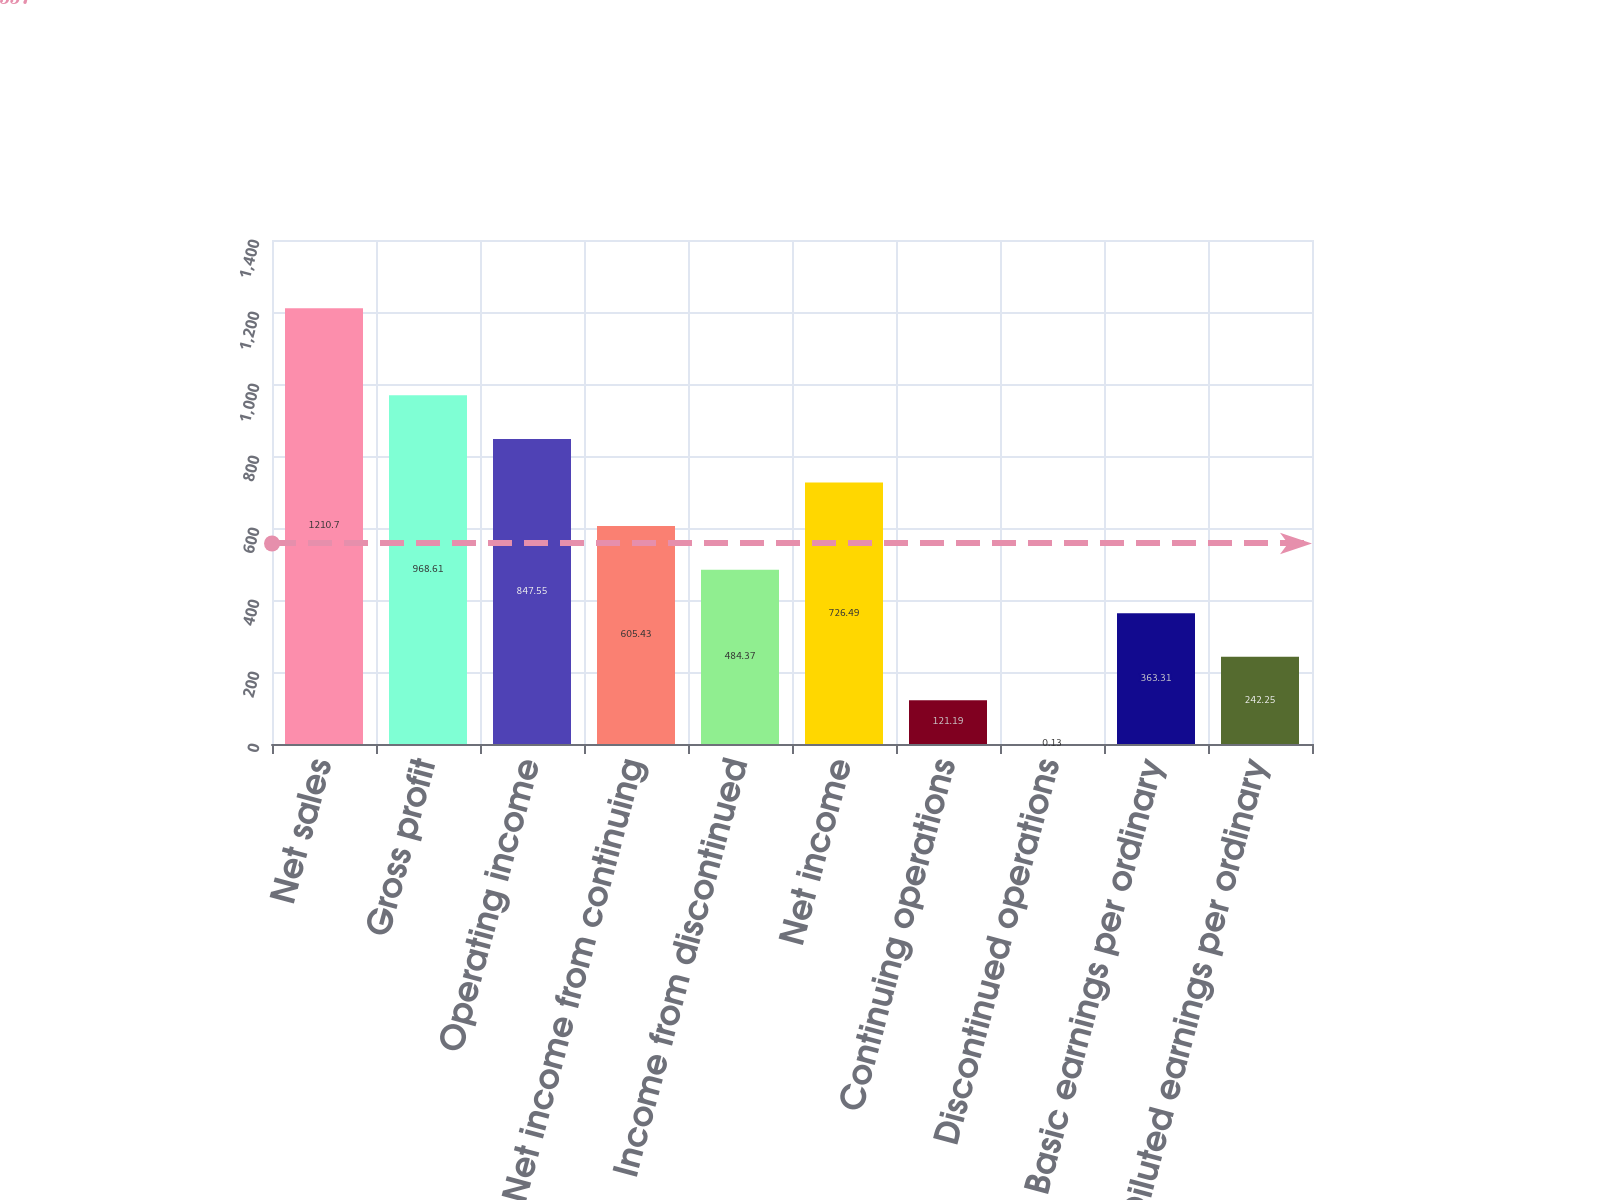<chart> <loc_0><loc_0><loc_500><loc_500><bar_chart><fcel>Net sales<fcel>Gross profit<fcel>Operating income<fcel>Net income from continuing<fcel>Income from discontinued<fcel>Net income<fcel>Continuing operations<fcel>Discontinued operations<fcel>Basic earnings per ordinary<fcel>Diluted earnings per ordinary<nl><fcel>1210.7<fcel>968.61<fcel>847.55<fcel>605.43<fcel>484.37<fcel>726.49<fcel>121.19<fcel>0.13<fcel>363.31<fcel>242.25<nl></chart> 